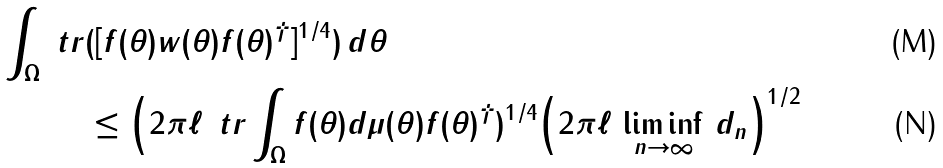Convert formula to latex. <formula><loc_0><loc_0><loc_500><loc_500>\int _ { \Omega } \ t r & ( [ f ( \theta ) w ( \theta ) f ( \theta ) ^ { \dagger } ] ^ { 1 / 4 } ) \, d \theta \\ & \leq \Big ( 2 \pi \ell \, \ t r \int _ { \Omega } f ( \theta ) d \mu ( \theta ) f ( \theta ) ^ { \dagger } ) ^ { 1 / 4 } \Big ( 2 \pi \ell \, \liminf _ { n \to \infty } \, d _ { n } \Big ) ^ { 1 / 2 }</formula> 